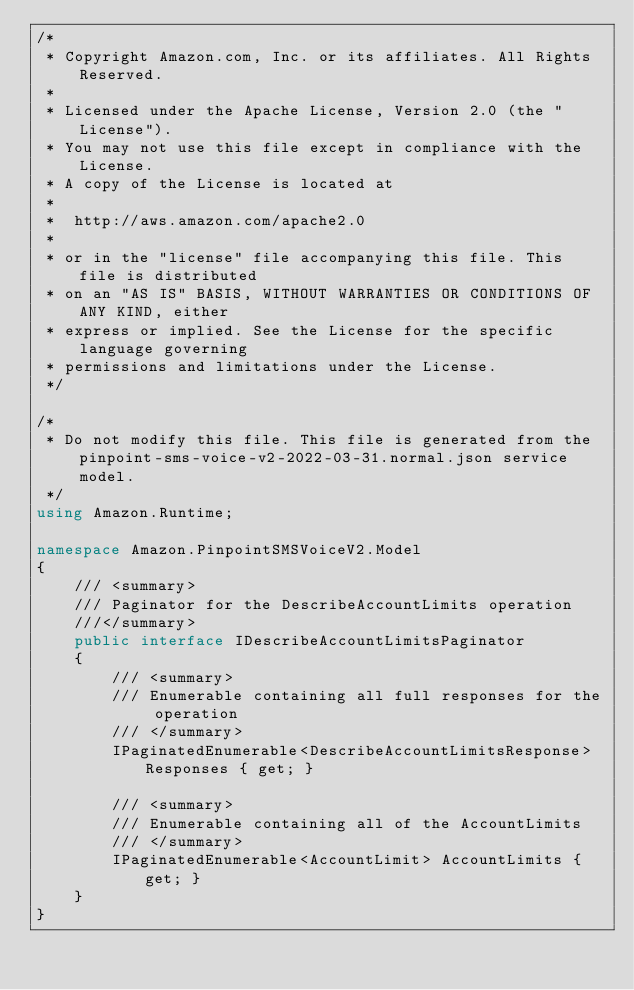Convert code to text. <code><loc_0><loc_0><loc_500><loc_500><_C#_>/*
 * Copyright Amazon.com, Inc. or its affiliates. All Rights Reserved.
 * 
 * Licensed under the Apache License, Version 2.0 (the "License").
 * You may not use this file except in compliance with the License.
 * A copy of the License is located at
 * 
 *  http://aws.amazon.com/apache2.0
 * 
 * or in the "license" file accompanying this file. This file is distributed
 * on an "AS IS" BASIS, WITHOUT WARRANTIES OR CONDITIONS OF ANY KIND, either
 * express or implied. See the License for the specific language governing
 * permissions and limitations under the License.
 */

/*
 * Do not modify this file. This file is generated from the pinpoint-sms-voice-v2-2022-03-31.normal.json service model.
 */
using Amazon.Runtime;

namespace Amazon.PinpointSMSVoiceV2.Model
{
    /// <summary>
    /// Paginator for the DescribeAccountLimits operation
    ///</summary>
    public interface IDescribeAccountLimitsPaginator
    {
        /// <summary>
        /// Enumerable containing all full responses for the operation
        /// </summary>
        IPaginatedEnumerable<DescribeAccountLimitsResponse> Responses { get; }

        /// <summary>
        /// Enumerable containing all of the AccountLimits
        /// </summary>
        IPaginatedEnumerable<AccountLimit> AccountLimits { get; }
    }
}</code> 